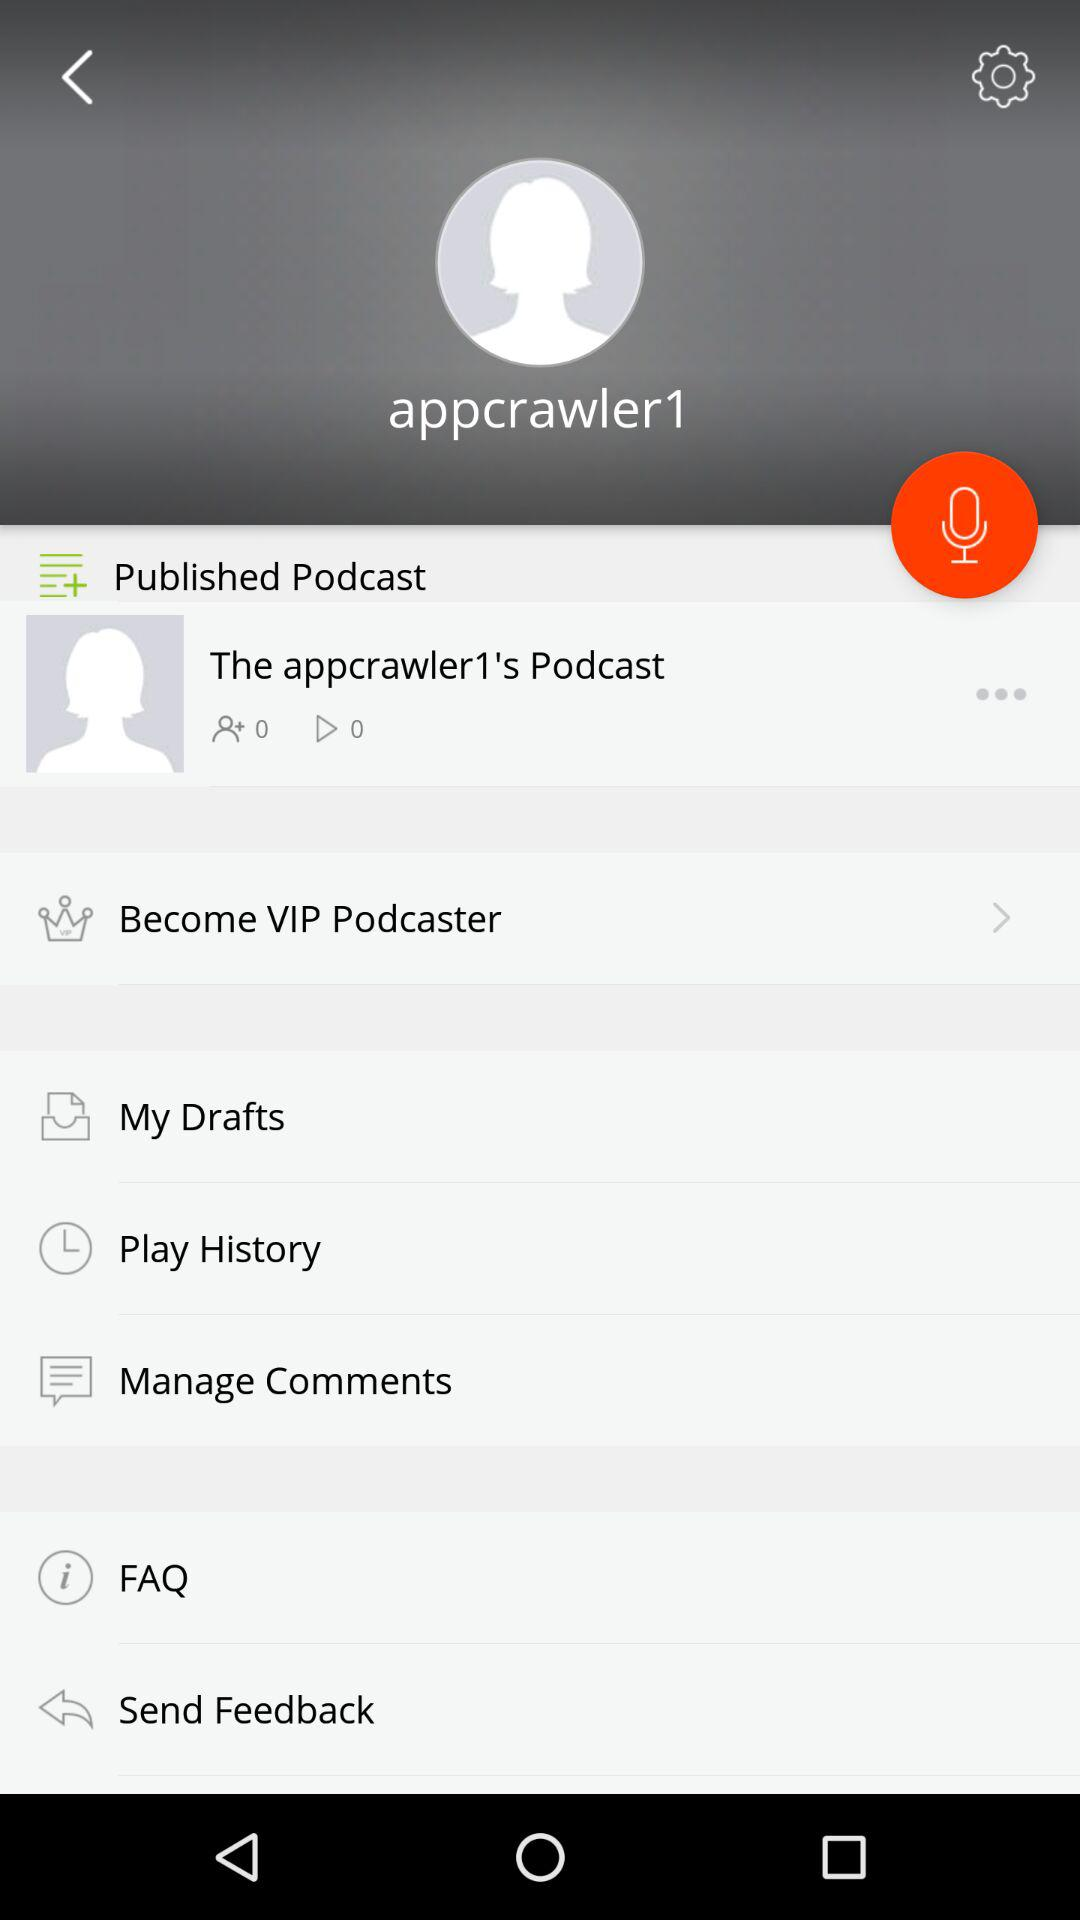How many times is the podcast played? The podcast has been played 0 times. 